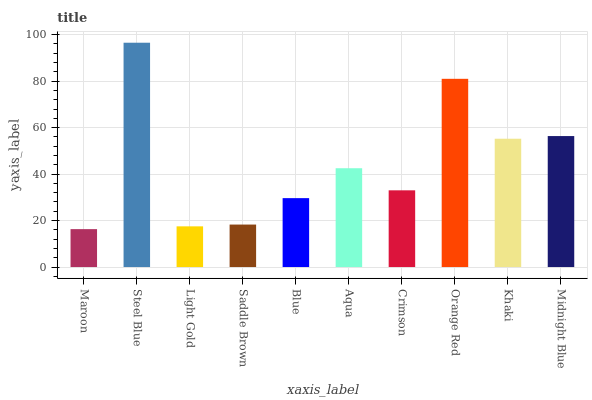Is Maroon the minimum?
Answer yes or no. Yes. Is Steel Blue the maximum?
Answer yes or no. Yes. Is Light Gold the minimum?
Answer yes or no. No. Is Light Gold the maximum?
Answer yes or no. No. Is Steel Blue greater than Light Gold?
Answer yes or no. Yes. Is Light Gold less than Steel Blue?
Answer yes or no. Yes. Is Light Gold greater than Steel Blue?
Answer yes or no. No. Is Steel Blue less than Light Gold?
Answer yes or no. No. Is Aqua the high median?
Answer yes or no. Yes. Is Crimson the low median?
Answer yes or no. Yes. Is Steel Blue the high median?
Answer yes or no. No. Is Midnight Blue the low median?
Answer yes or no. No. 